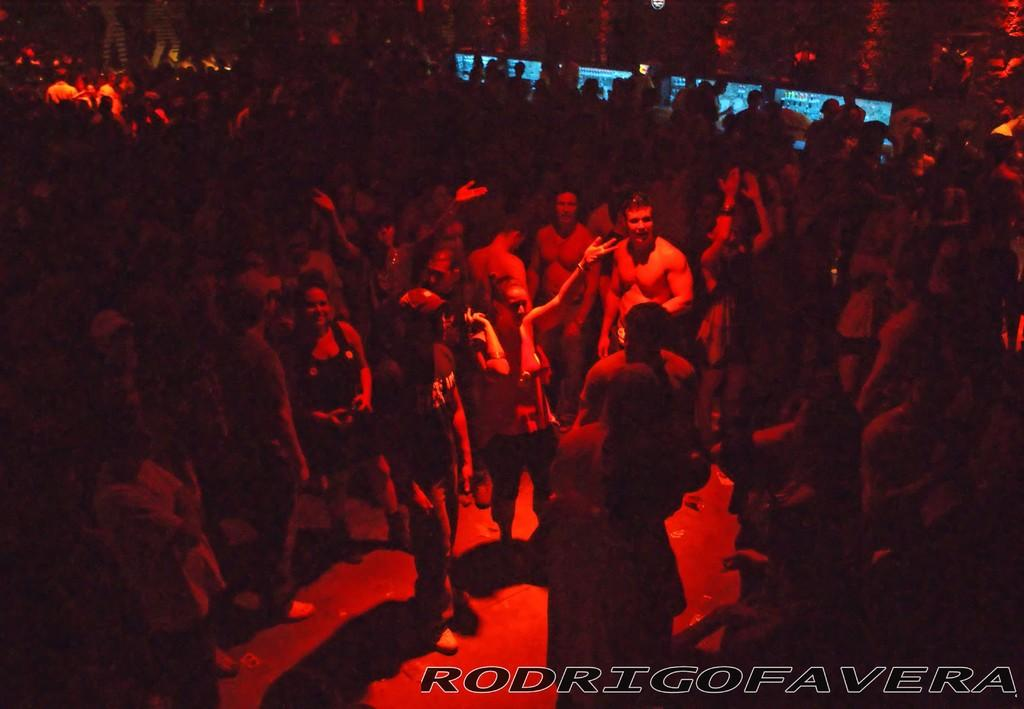Who or what can be seen in the image? There are people in the image. What else is present in the image besides the people? There is text in the bottom right side of the image. Can you describe the background of the image? The background of the image is dark. What type of drain is visible in the image? There is no drain present in the image. Is the hospital mentioned or depicted in the image? There is no mention or depiction of a hospital in the image. 